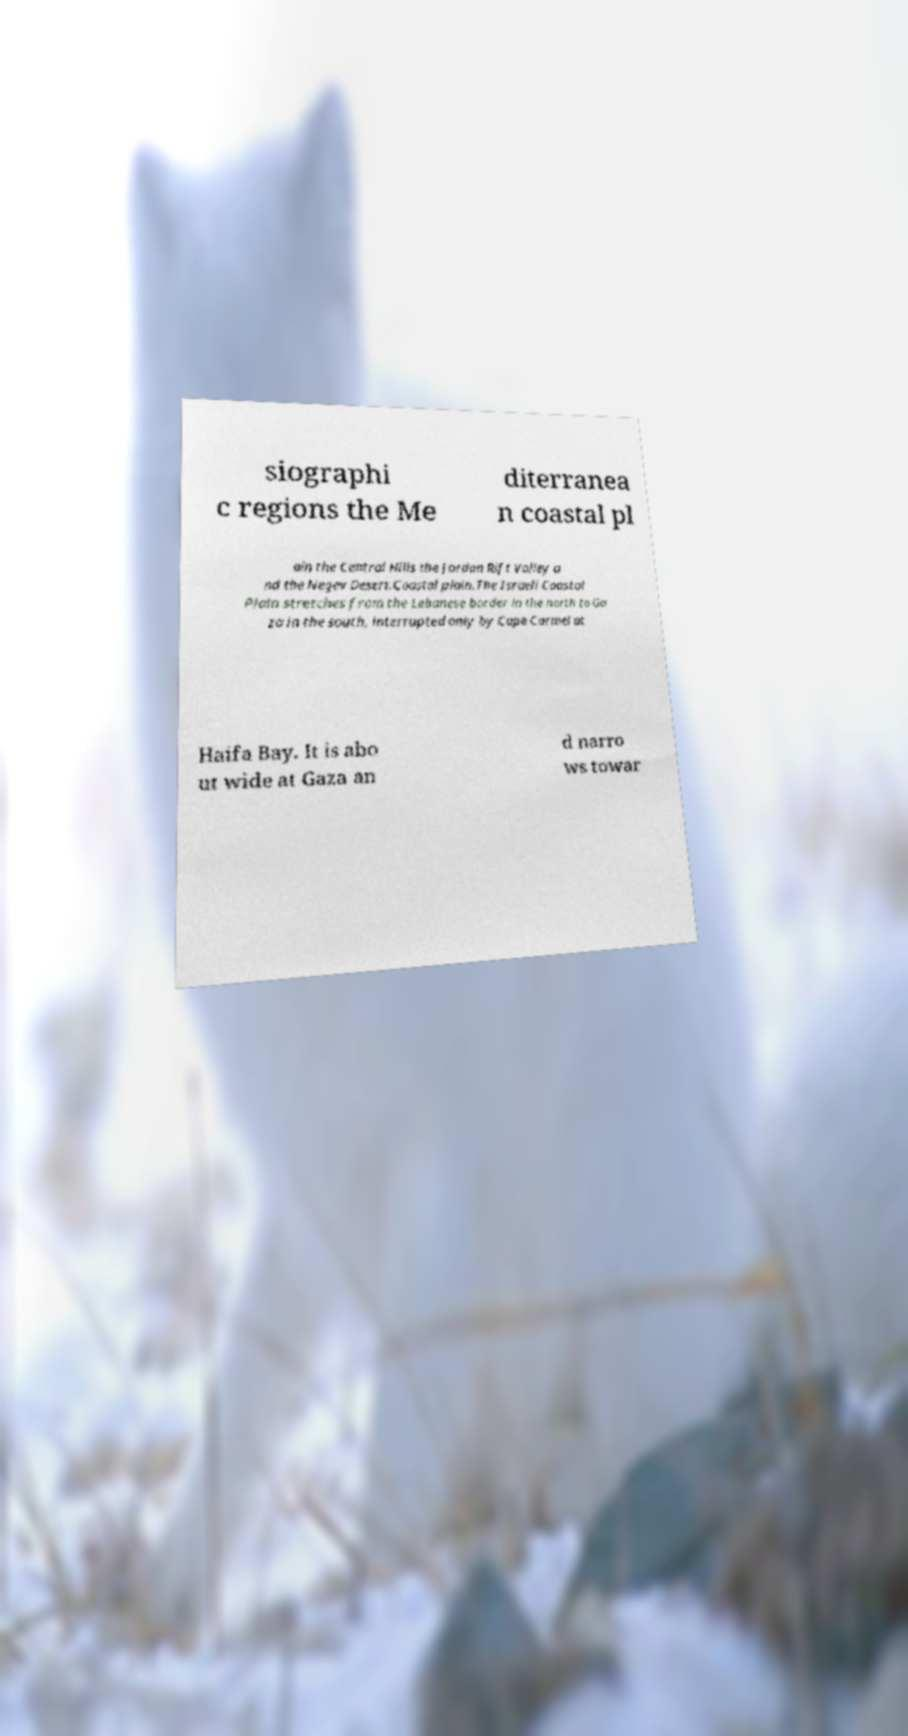Please identify and transcribe the text found in this image. siographi c regions the Me diterranea n coastal pl ain the Central Hills the Jordan Rift Valley a nd the Negev Desert.Coastal plain.The Israeli Coastal Plain stretches from the Lebanese border in the north to Ga za in the south, interrupted only by Cape Carmel at Haifa Bay. It is abo ut wide at Gaza an d narro ws towar 